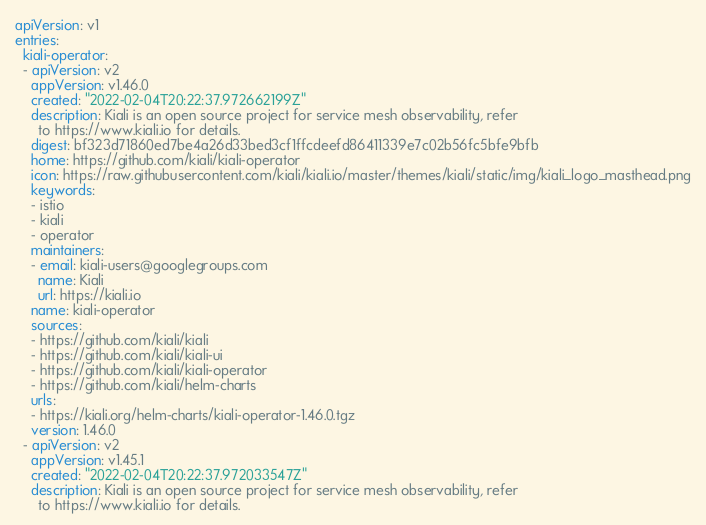<code> <loc_0><loc_0><loc_500><loc_500><_YAML_>apiVersion: v1
entries:
  kiali-operator:
  - apiVersion: v2
    appVersion: v1.46.0
    created: "2022-02-04T20:22:37.972662199Z"
    description: Kiali is an open source project for service mesh observability, refer
      to https://www.kiali.io for details.
    digest: bf323d71860ed7be4a26d33bed3cf1ffcdeefd86411339e7c02b56fc5bfe9bfb
    home: https://github.com/kiali/kiali-operator
    icon: https://raw.githubusercontent.com/kiali/kiali.io/master/themes/kiali/static/img/kiali_logo_masthead.png
    keywords:
    - istio
    - kiali
    - operator
    maintainers:
    - email: kiali-users@googlegroups.com
      name: Kiali
      url: https://kiali.io
    name: kiali-operator
    sources:
    - https://github.com/kiali/kiali
    - https://github.com/kiali/kiali-ui
    - https://github.com/kiali/kiali-operator
    - https://github.com/kiali/helm-charts
    urls:
    - https://kiali.org/helm-charts/kiali-operator-1.46.0.tgz
    version: 1.46.0
  - apiVersion: v2
    appVersion: v1.45.1
    created: "2022-02-04T20:22:37.972033547Z"
    description: Kiali is an open source project for service mesh observability, refer
      to https://www.kiali.io for details.</code> 